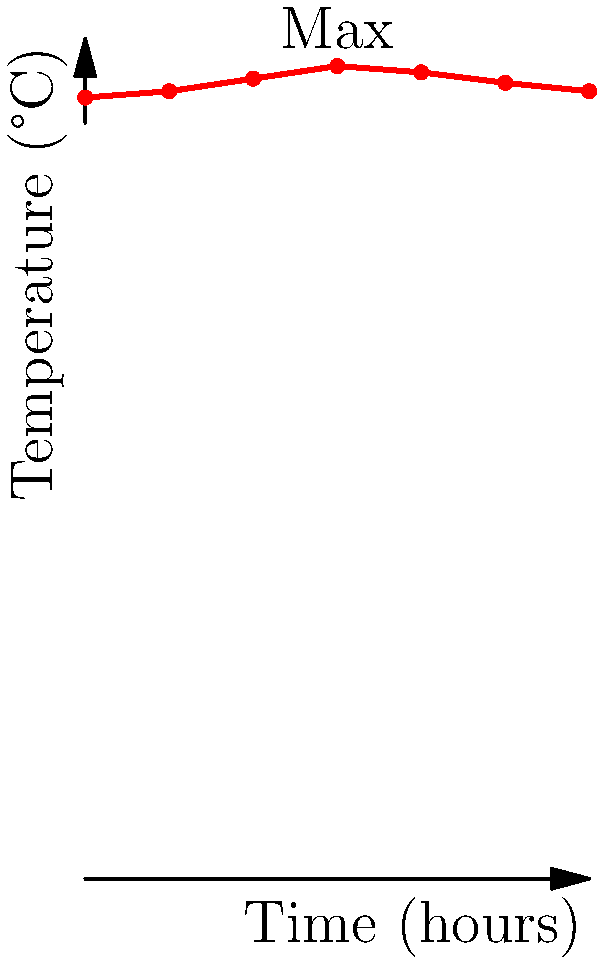The graph shows the body temperature of a patient over a 24-hour period. At what time did the patient's temperature reach its peak, and what was the maximum temperature recorded? To answer this question, we need to analyze the graph of the patient's temperature over time:

1. The x-axis represents time in hours, ranging from 0 to 24.
2. The y-axis represents temperature in degrees Celsius, ranging from 36°C to 40°C.
3. The red line represents the patient's temperature over time.
4. We need to find the highest point on this line.

Examining the graph:

1. The temperature starts at 37.2°C at 0 hours.
2. It gradually increases over time.
3. The highest point on the graph is clearly marked with a "Max" label.
4. This point corresponds to 12 hours on the x-axis and 38.7°C on the y-axis.

Therefore, the patient's temperature reached its peak at 12 hours (or 12:00) into the monitoring period, and the maximum temperature recorded was 38.7°C.
Answer: 12 hours, 38.7°C 